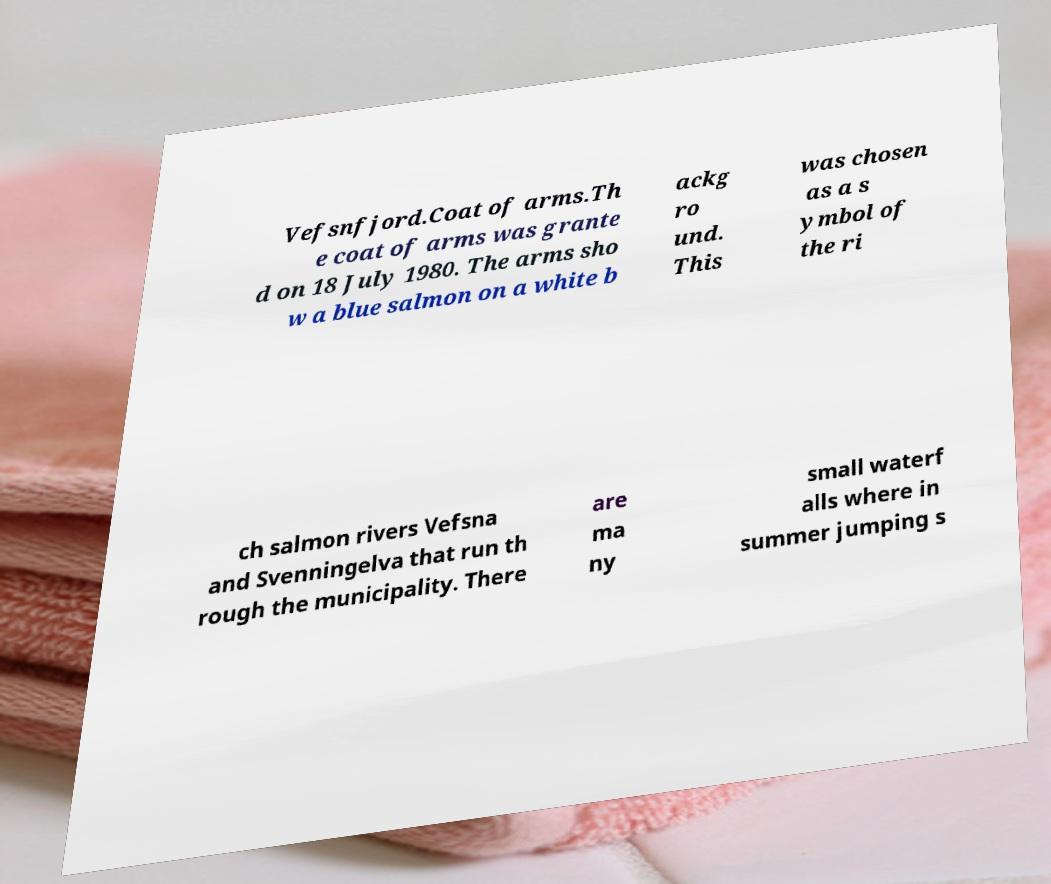What messages or text are displayed in this image? I need them in a readable, typed format. Vefsnfjord.Coat of arms.Th e coat of arms was grante d on 18 July 1980. The arms sho w a blue salmon on a white b ackg ro und. This was chosen as a s ymbol of the ri ch salmon rivers Vefsna and Svenningelva that run th rough the municipality. There are ma ny small waterf alls where in summer jumping s 